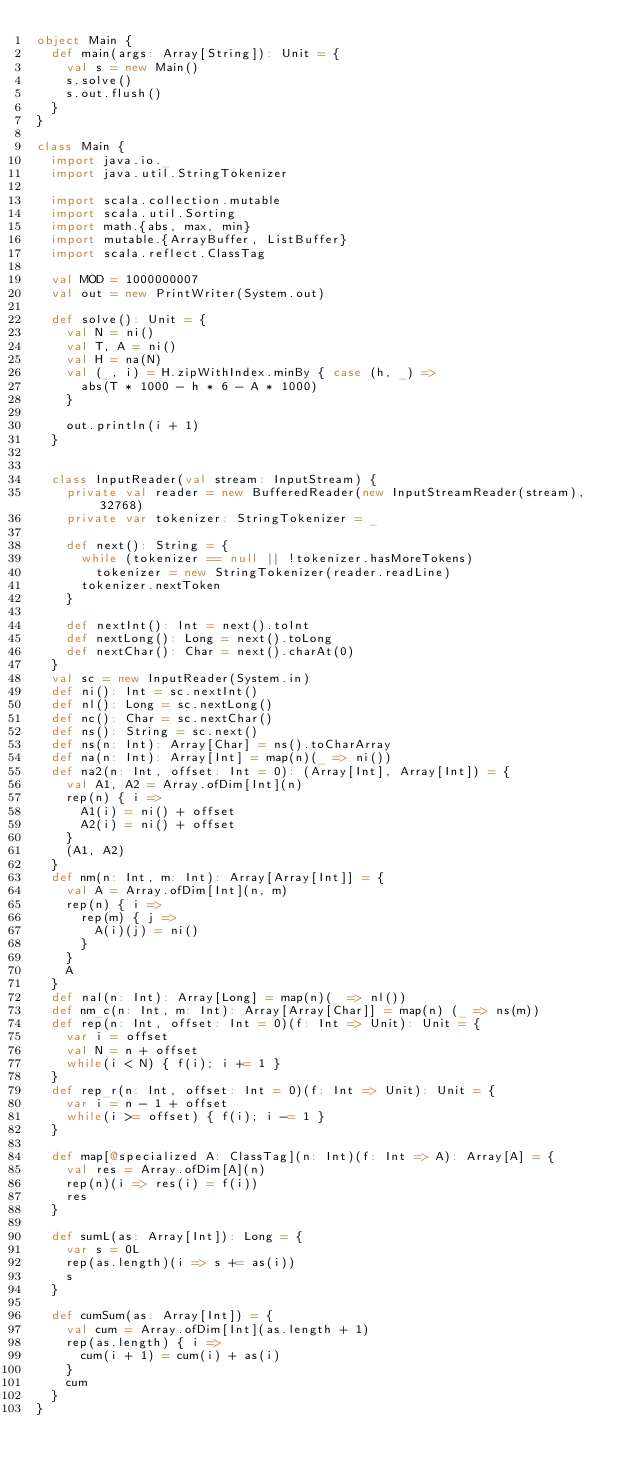<code> <loc_0><loc_0><loc_500><loc_500><_Scala_>object Main {
  def main(args: Array[String]): Unit = {
    val s = new Main()
    s.solve()
    s.out.flush()
  }
}

class Main {
  import java.io._
  import java.util.StringTokenizer

  import scala.collection.mutable
  import scala.util.Sorting
  import math.{abs, max, min}
  import mutable.{ArrayBuffer, ListBuffer}
  import scala.reflect.ClassTag

  val MOD = 1000000007
  val out = new PrintWriter(System.out)

  def solve(): Unit = {
    val N = ni()
    val T, A = ni()
    val H = na(N)
    val (_, i) = H.zipWithIndex.minBy { case (h, _) =>
      abs(T * 1000 - h * 6 - A * 1000)
    }

    out.println(i + 1)
  }


  class InputReader(val stream: InputStream) {
    private val reader = new BufferedReader(new InputStreamReader(stream), 32768)
    private var tokenizer: StringTokenizer = _

    def next(): String = {
      while (tokenizer == null || !tokenizer.hasMoreTokens)
        tokenizer = new StringTokenizer(reader.readLine)
      tokenizer.nextToken
    }

    def nextInt(): Int = next().toInt
    def nextLong(): Long = next().toLong
    def nextChar(): Char = next().charAt(0)
  }
  val sc = new InputReader(System.in)
  def ni(): Int = sc.nextInt()
  def nl(): Long = sc.nextLong()
  def nc(): Char = sc.nextChar()
  def ns(): String = sc.next()
  def ns(n: Int): Array[Char] = ns().toCharArray
  def na(n: Int): Array[Int] = map(n)(_ => ni())
  def na2(n: Int, offset: Int = 0): (Array[Int], Array[Int]) = {
    val A1, A2 = Array.ofDim[Int](n)
    rep(n) { i =>
      A1(i) = ni() + offset
      A2(i) = ni() + offset
    }
    (A1, A2)
  }
  def nm(n: Int, m: Int): Array[Array[Int]] = {
    val A = Array.ofDim[Int](n, m)
    rep(n) { i =>
      rep(m) { j =>
        A(i)(j) = ni()
      }
    }
    A
  }
  def nal(n: Int): Array[Long] = map(n)(_ => nl())
  def nm_c(n: Int, m: Int): Array[Array[Char]] = map(n) (_ => ns(m))
  def rep(n: Int, offset: Int = 0)(f: Int => Unit): Unit = {
    var i = offset
    val N = n + offset
    while(i < N) { f(i); i += 1 }
  }
  def rep_r(n: Int, offset: Int = 0)(f: Int => Unit): Unit = {
    var i = n - 1 + offset
    while(i >= offset) { f(i); i -= 1 }
  }

  def map[@specialized A: ClassTag](n: Int)(f: Int => A): Array[A] = {
    val res = Array.ofDim[A](n)
    rep(n)(i => res(i) = f(i))
    res
  }

  def sumL(as: Array[Int]): Long = {
    var s = 0L
    rep(as.length)(i => s += as(i))
    s
  }

  def cumSum(as: Array[Int]) = {
    val cum = Array.ofDim[Int](as.length + 1)
    rep(as.length) { i =>
      cum(i + 1) = cum(i) + as(i)
    }
    cum
  }
}</code> 